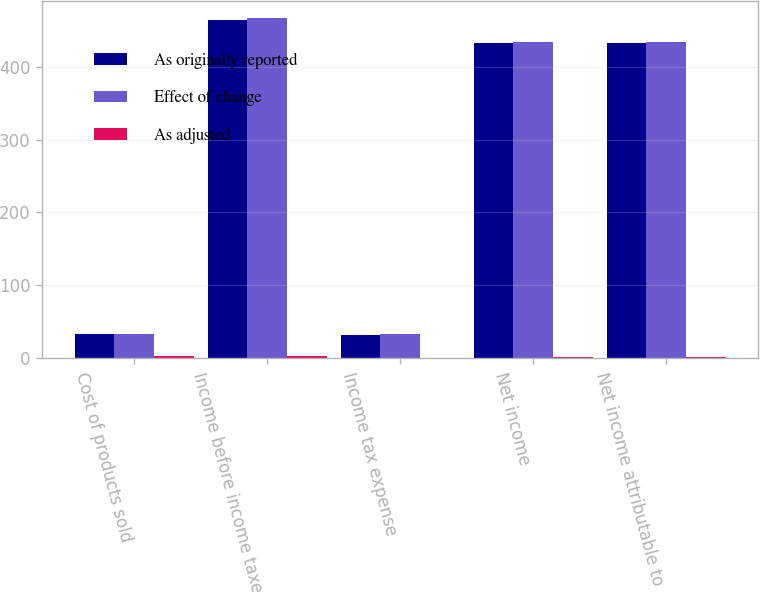Convert chart. <chart><loc_0><loc_0><loc_500><loc_500><stacked_bar_chart><ecel><fcel>Cost of products sold<fcel>Income before income taxes<fcel>Income tax expense<fcel>Net income<fcel>Net income attributable to<nl><fcel>As originally reported<fcel>33<fcel>464<fcel>32<fcel>432<fcel>432<nl><fcel>Effect of change<fcel>33<fcel>467<fcel>33<fcel>434<fcel>434<nl><fcel>As adjusted<fcel>3<fcel>3<fcel>1<fcel>2<fcel>2<nl></chart> 